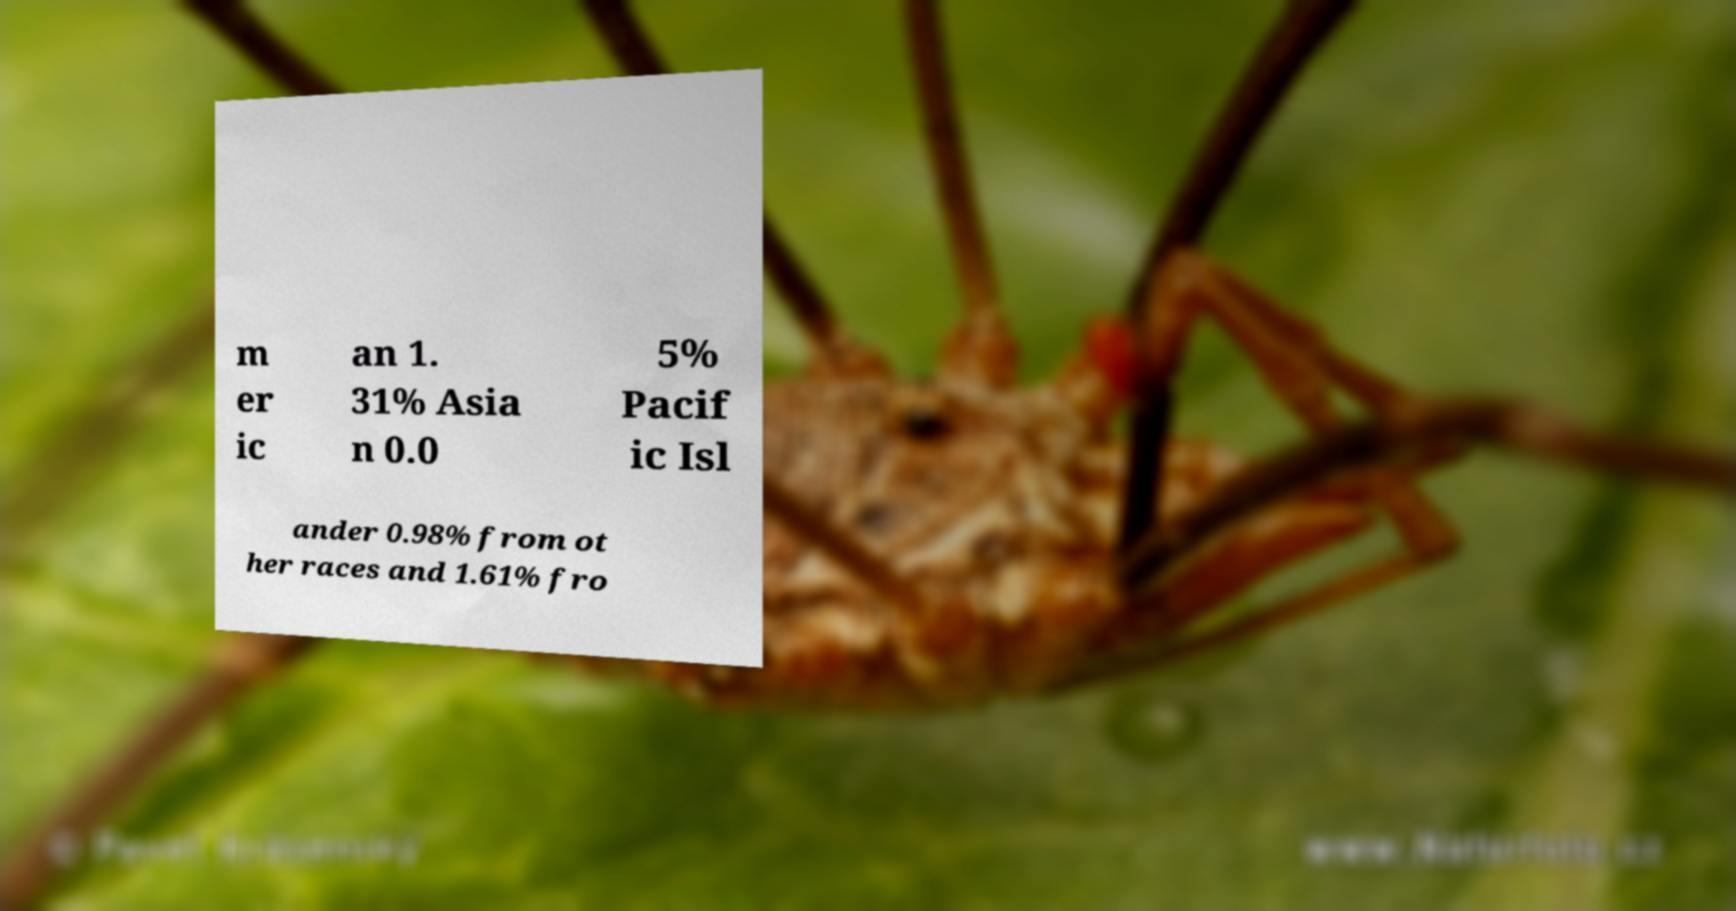I need the written content from this picture converted into text. Can you do that? m er ic an 1. 31% Asia n 0.0 5% Pacif ic Isl ander 0.98% from ot her races and 1.61% fro 